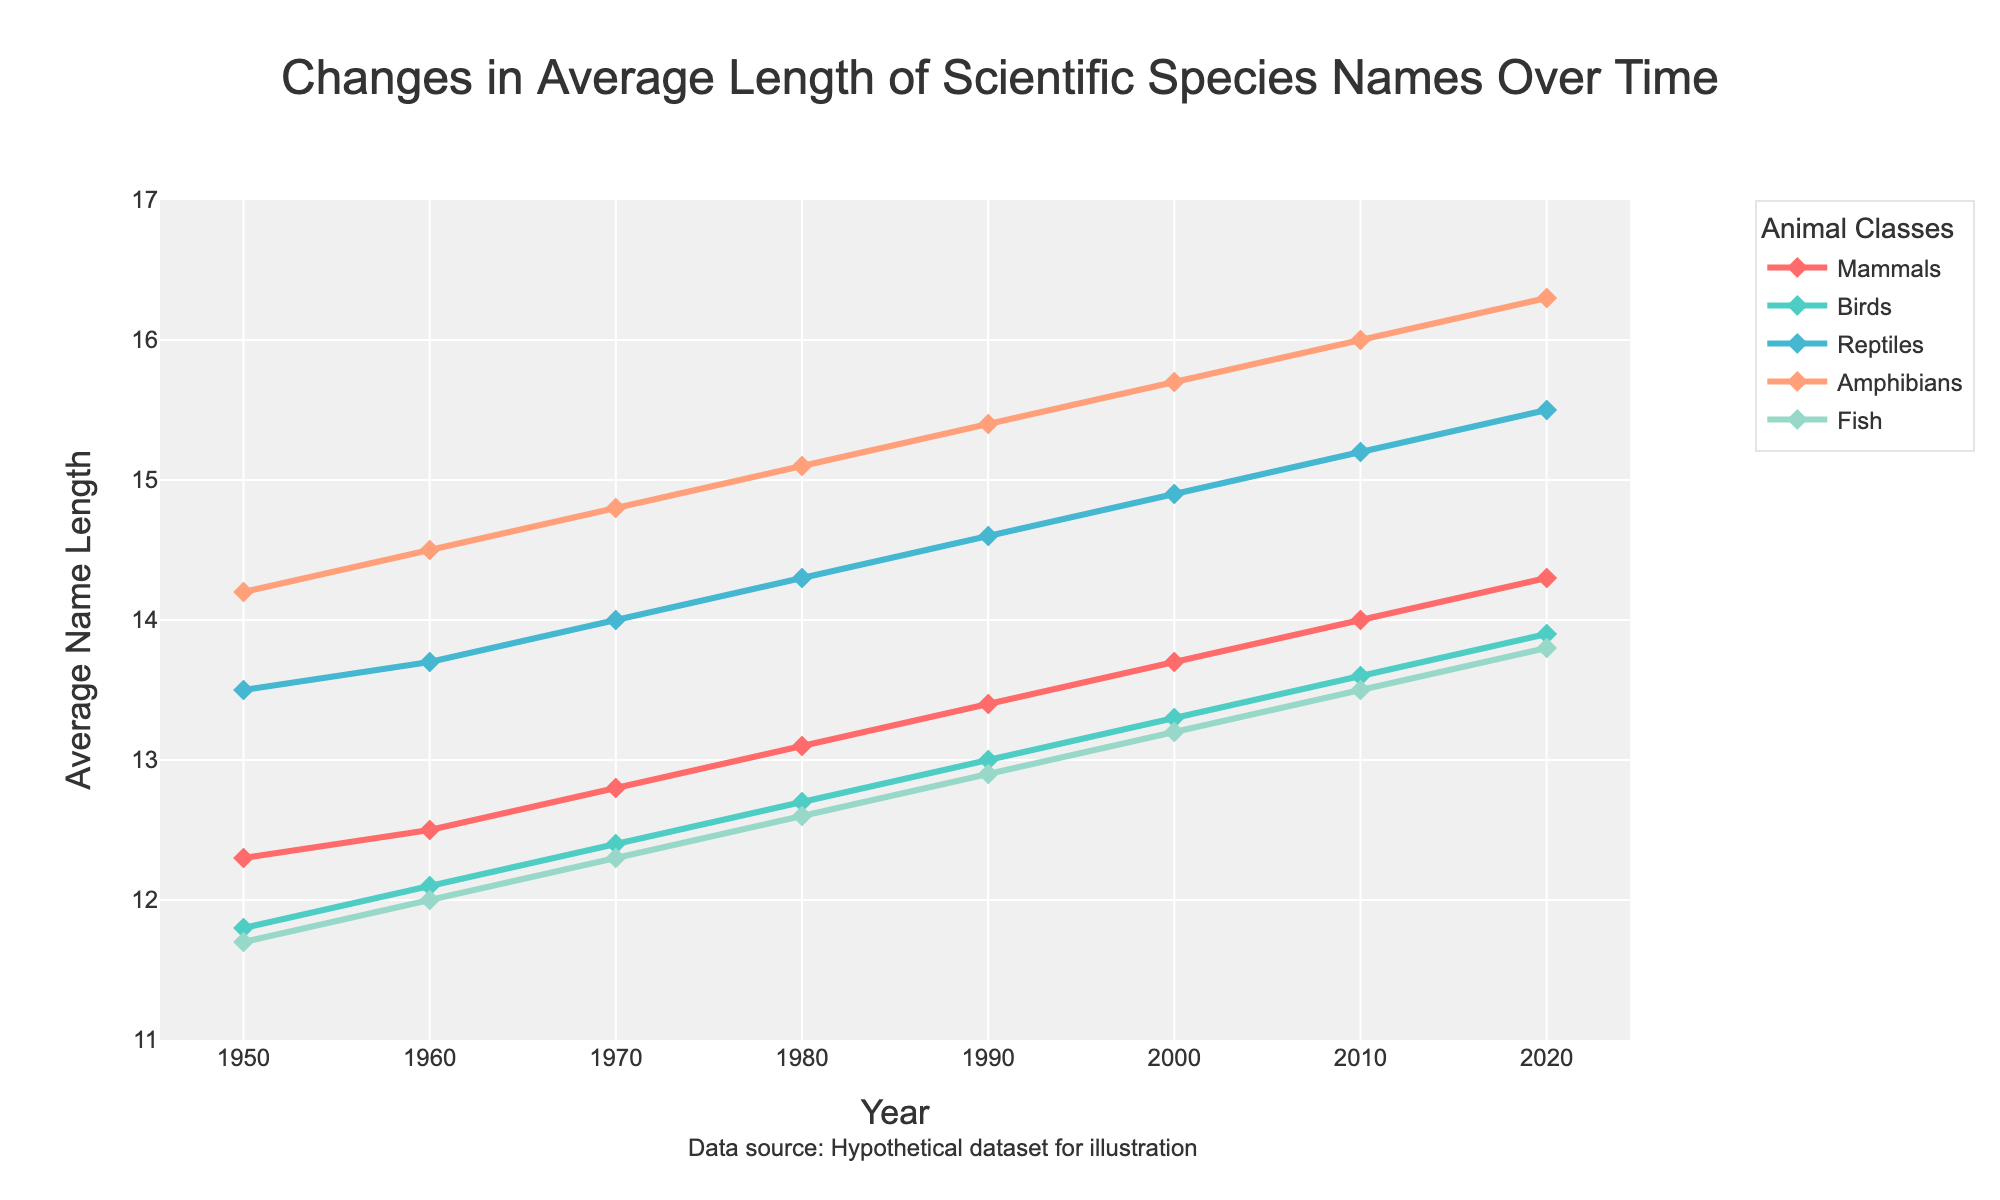Which animal class had the longest average scientific name length in 1950? Check the data point for 1950 across all animal classes. Amphibians have the longest average name length at 14.2.
Answer: Amphibians What is the difference in the average scientific name length of Mammals between 1950 and 2020? Subtract the average name length of Mammals in 1950 (12.3) from that in 2020 (14.3). Calculation: 14.3 - 12.3 = 2.0
Answer: 2.0 Between which two years did Birds show the most significant increase in average name length? Compare the increase in average name length for Birds year over year. The greatest increase is between 2010 and 2020, where it goes from 13.6 to 13.9.
Answer: 2010 and 2020 What is the trend for the average scientific name length of Fish from 1950 to 2020? Observe the line for Fish from 1950 to 2020. It shows a consistent upward trend.
Answer: Upward trend In 1980, which animal class had the shortest average scientific name length? Check the data point for 1980 across all animal classes. Fish has the shortest average name length at 12.6.
Answer: Fish What is the average scientific name length for Reptiles in 2000? Identify the data point for Reptiles in 2000, which is 14.9.
Answer: 14.9 Which animal class showed the steepest increase in average scientific name length between 1950 and 2020? Calculate the total increase for each class from 1950 to 2020: Mammals (14.3 - 12.3 = 2.0), Birds (13.9 - 11.8 = 2.1), Reptiles (15.5 - 13.5 = 2.0), Amphibians (16.3 - 14.2 = 2.1), Fish (13.8 - 11.7 = 2.1). Birds, Amphibians, and Fish all increase by 2.1.
Answer: Birds, Amphibians, Fish Which animal class had the largest average name length difference between 1990 and 2000? Calculate the difference for each class: Mammals (13.7 - 13.4 = 0.3), Birds (13.3 - 13.0 = 0.3), Reptiles (14.9 - 14.6 = 0.3), Amphibians (15.7 - 15.4 = 0.3), Fish (13.2 - 12.9 = 0.3). All show the same difference.
Answer: All equal (0.3) 